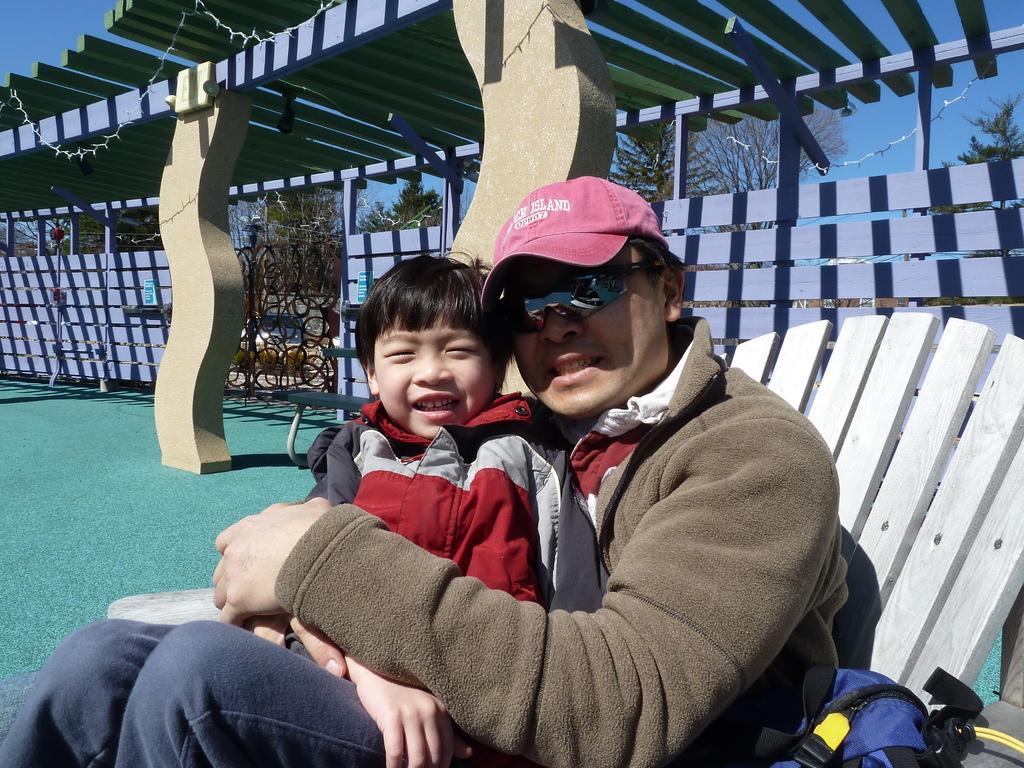Please provide a concise description of this image. In this picture I can observe a man and boy sitting on the chair in the middle of the picture. Man is wearing spectacles and cap on his head. In the background I can observe wooden wall and some trees. 